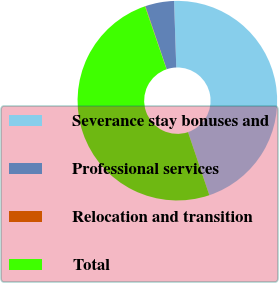Convert chart. <chart><loc_0><loc_0><loc_500><loc_500><pie_chart><fcel>Severance stay bonuses and<fcel>Professional services<fcel>Relocation and transition<fcel>Total<nl><fcel>45.33%<fcel>4.67%<fcel>0.07%<fcel>49.93%<nl></chart> 